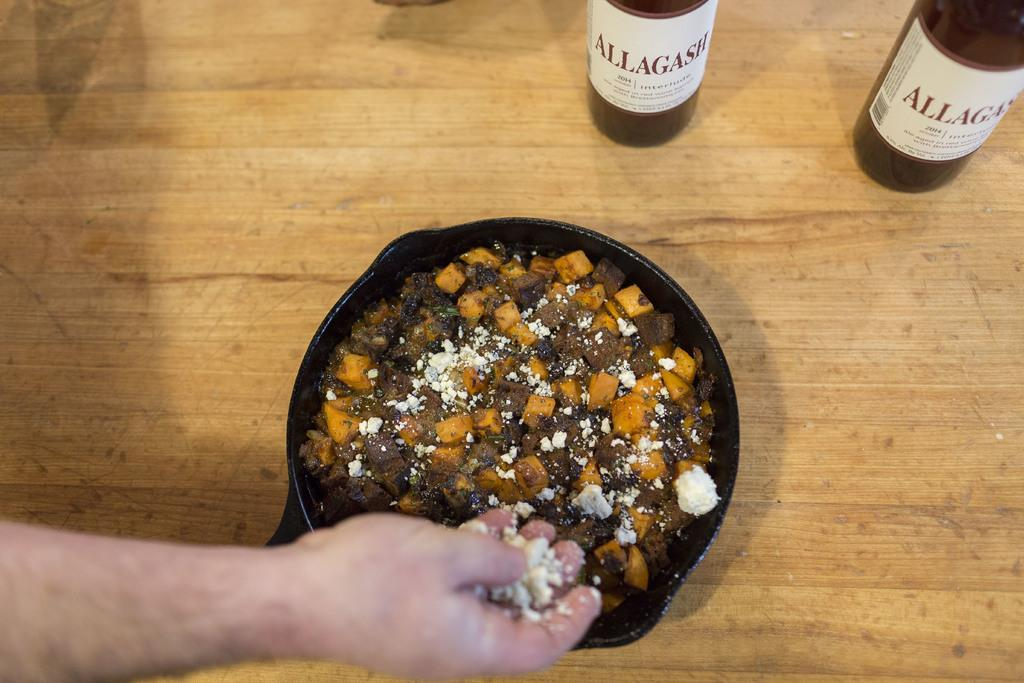<image>
Give a short and clear explanation of the subsequent image. Two bottles of Allagash wine next to a bowl of food 